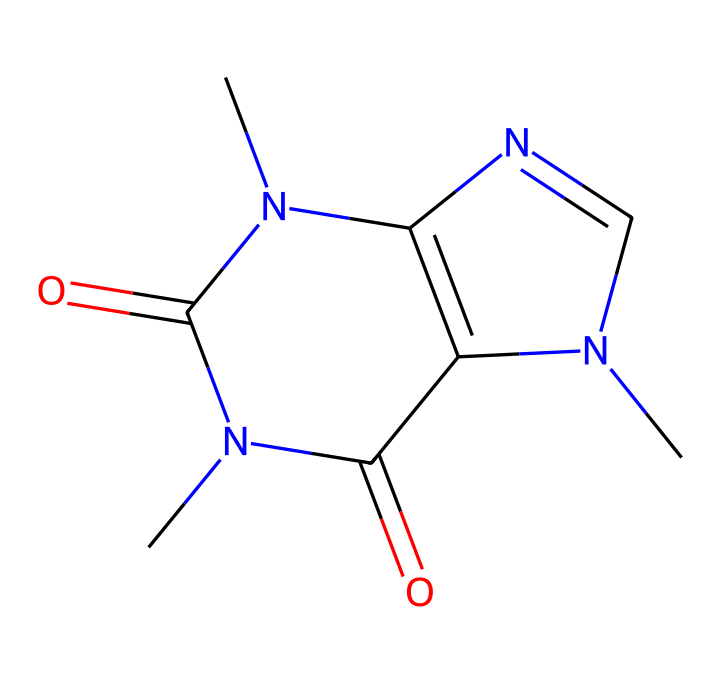How many nitrogen atoms are present in this compound? The SMILES representation shows "N" appearing twice, indicating there are two nitrogen atoms in the structure.
Answer: two What is the total number of carbon atoms in this molecule? By analyzing the SMILES, we can count each "C". There are five "C" in the representation, confirming that there are five carbon atoms in total.
Answer: five Which functional groups are suggested by the presence of "O" in the structure? The presence of "O" in the SMILES indicates that there are carbonyl (C=O) groups, specifically shown by the "C(=O)" portions, suggesting there are amides.
Answer: amides What type of medicinal compound is caffeine classified as? The structure features multiple nitrogen atoms and a complex ring system, categorizing caffeine as an alkaloid based on its biomedical effects.
Answer: alkaloid What is the molecular formula of caffeine? The molecular formula can be deduced from the SMILES: there are five carbons, four nitrogens, and two oxygens, leading to the formula C8H10N4O2.
Answer: C8H10N4O2 How does the structure of caffeine contribute to its stimulant effects? The multiple nitrogen atoms in caffeine's structure allow for interactions with adenosine receptors in the brain, which block drowsiness, hence contributing to its stimulant effects.
Answer: adenosine receptors What effect does the methylene group have in the molecular structure? The methylene group (–CH2–) often influences the molecule's solubility and bioavailability; in caffeine, it helps the compound remain lipophilic, allowing for better absorption.
Answer: lipophilic 